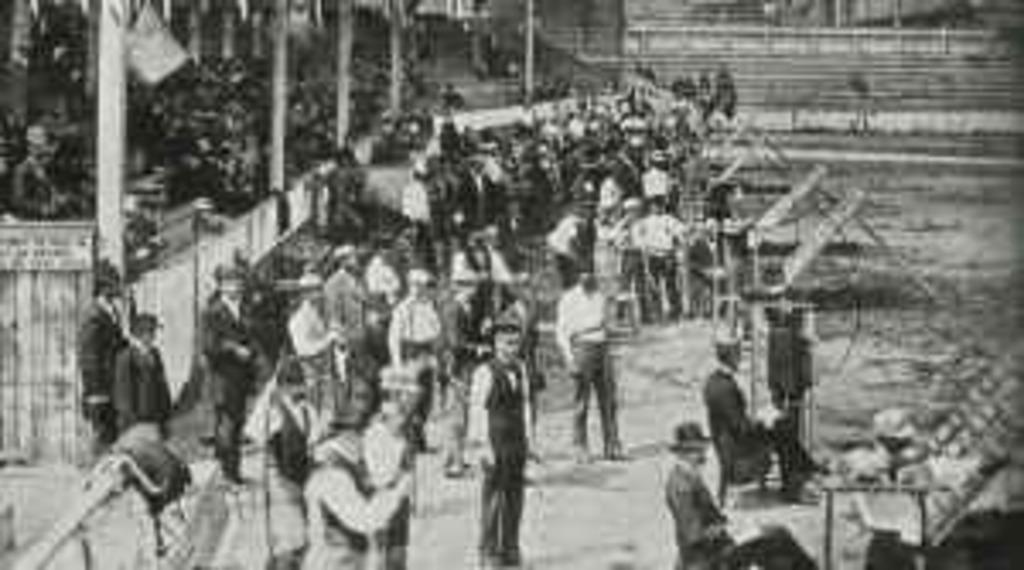What is the color scheme of the image? The image is black and white. What are the people in the image doing? There are groups of people standing and people sitting in the image. What architectural feature can be seen in the image? There are pillars visible in the image. What shape is the basketball in the image? There is no basketball present in the image. What type of loss is depicted in the image? The image does not depict any loss; it features groups of people standing and sitting, as well as pillars. 